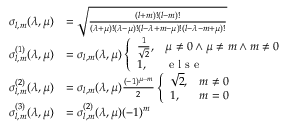<formula> <loc_0><loc_0><loc_500><loc_500>\begin{array} { r l } { \sigma _ { l , m } ( \lambda , \mu ) } & { = \sqrt { \frac { ( l + m ) ! ( l - m ) ! } { ( \lambda + \mu ) ! ( \lambda - \mu ) ! ( l - \lambda + m - \mu ) ! ( l - \lambda - m + \mu ) ! } } } \\ { \sigma _ { l , m } ^ { ( 1 ) } ( \lambda , \mu ) } & { = \sigma _ { l , m } ( \lambda , \mu ) \left \{ \begin{array} { l l } { \frac { 1 } { \sqrt { 2 } } , } & { \mu \neq 0 \land \mu \neq m \land m \neq 0 } \\ { 1 , } & { e l s e } \end{array} } \\ { \sigma _ { l , m } ^ { ( 2 ) } ( \lambda , \mu ) } & { = \sigma _ { l , m } ( \lambda , \mu ) \frac { ( - 1 ) ^ { \mu - m } } { 2 } \left \{ \begin{array} { l l } { \sqrt { 2 } , } & { m \neq 0 } \\ { 1 , } & { m = 0 } \end{array} } \\ { \sigma _ { l , m } ^ { ( 3 ) } ( \lambda , \mu ) } & { = \sigma _ { l , m } ^ { ( 2 ) } ( \lambda , \mu ) ( - 1 ) ^ { m } } \end{array}</formula> 